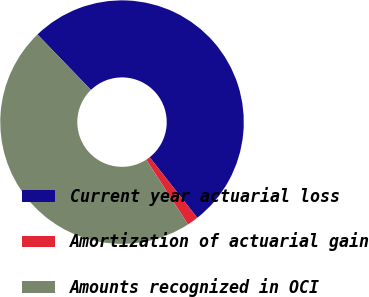<chart> <loc_0><loc_0><loc_500><loc_500><pie_chart><fcel>Current year actuarial loss<fcel>Amortization of actuarial gain<fcel>Amounts recognized in OCI<nl><fcel>51.61%<fcel>1.49%<fcel>46.9%<nl></chart> 